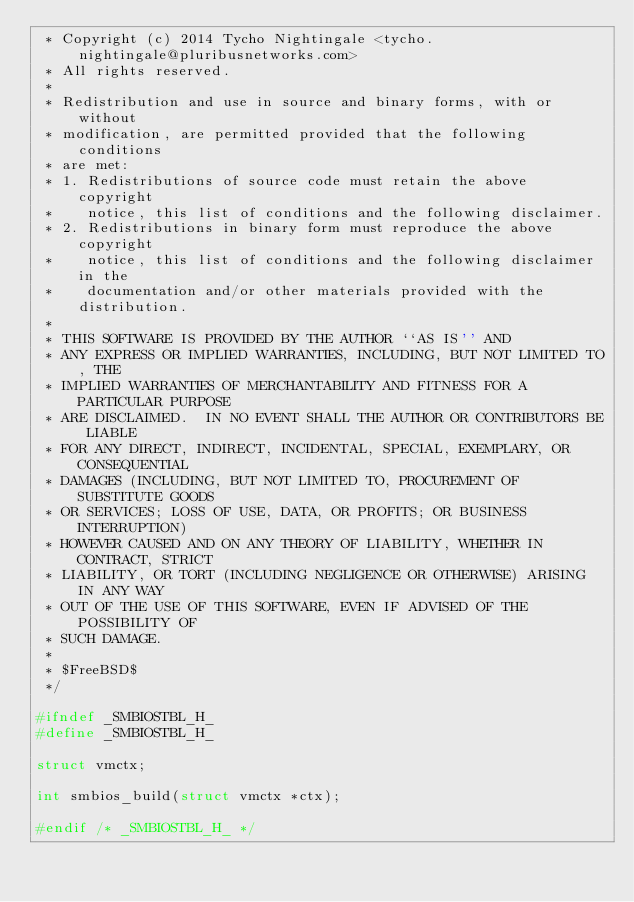Convert code to text. <code><loc_0><loc_0><loc_500><loc_500><_C_> * Copyright (c) 2014 Tycho Nightingale <tycho.nightingale@pluribusnetworks.com>
 * All rights reserved.
 *
 * Redistribution and use in source and binary forms, with or without
 * modification, are permitted provided that the following conditions
 * are met:
 * 1. Redistributions of source code must retain the above copyright
 *    notice, this list of conditions and the following disclaimer.
 * 2. Redistributions in binary form must reproduce the above copyright
 *    notice, this list of conditions and the following disclaimer in the
 *    documentation and/or other materials provided with the distribution.
 *
 * THIS SOFTWARE IS PROVIDED BY THE AUTHOR ``AS IS'' AND
 * ANY EXPRESS OR IMPLIED WARRANTIES, INCLUDING, BUT NOT LIMITED TO, THE
 * IMPLIED WARRANTIES OF MERCHANTABILITY AND FITNESS FOR A PARTICULAR PURPOSE
 * ARE DISCLAIMED.  IN NO EVENT SHALL THE AUTHOR OR CONTRIBUTORS BE LIABLE
 * FOR ANY DIRECT, INDIRECT, INCIDENTAL, SPECIAL, EXEMPLARY, OR CONSEQUENTIAL
 * DAMAGES (INCLUDING, BUT NOT LIMITED TO, PROCUREMENT OF SUBSTITUTE GOODS
 * OR SERVICES; LOSS OF USE, DATA, OR PROFITS; OR BUSINESS INTERRUPTION)
 * HOWEVER CAUSED AND ON ANY THEORY OF LIABILITY, WHETHER IN CONTRACT, STRICT
 * LIABILITY, OR TORT (INCLUDING NEGLIGENCE OR OTHERWISE) ARISING IN ANY WAY
 * OUT OF THE USE OF THIS SOFTWARE, EVEN IF ADVISED OF THE POSSIBILITY OF
 * SUCH DAMAGE.
 *
 * $FreeBSD$
 */

#ifndef _SMBIOSTBL_H_
#define _SMBIOSTBL_H_

struct vmctx;

int	smbios_build(struct vmctx *ctx);

#endif /* _SMBIOSTBL_H_ */
</code> 